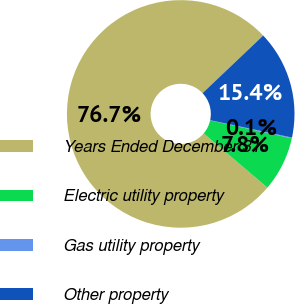Convert chart to OTSL. <chart><loc_0><loc_0><loc_500><loc_500><pie_chart><fcel>Years Ended December 31<fcel>Electric utility property<fcel>Gas utility property<fcel>Other property<nl><fcel>76.69%<fcel>7.77%<fcel>0.11%<fcel>15.43%<nl></chart> 